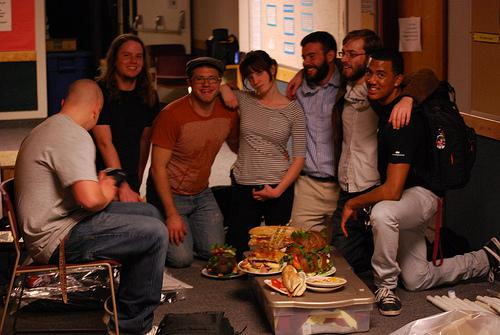Question: who is in the photo?
Choices:
A. A group of seven people.
B. A family.
C. Men and women.
D. Children.
Answer with the letter. Answer: A Question: why are they looking at the camera?
Choices:
A. There's something behind the photographer.
B. They are posing for a picture.
C. They are wondering why he's taking their picture.
D. They want to be photographed.
Answer with the letter. Answer: B Question: when was the photo taken?
Choices:
A. Summer.
B. Spring.
C. At a birthday party.
D. At a gathering.
Answer with the letter. Answer: D Question: what is in the middle of the group?
Choices:
A. Drinks.
B. Food.
C. Plates.
D. Silverware.
Answer with the letter. Answer: B 